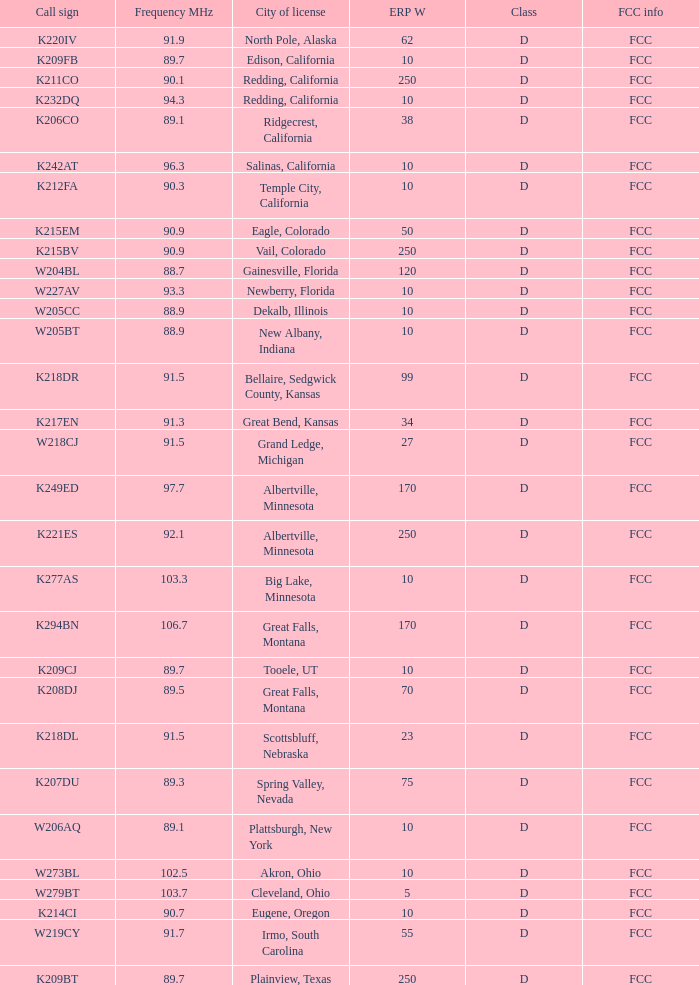What is the call sign of the translator with an ERP W greater than 38 and a city license from Great Falls, Montana? K294BN, K208DJ. 